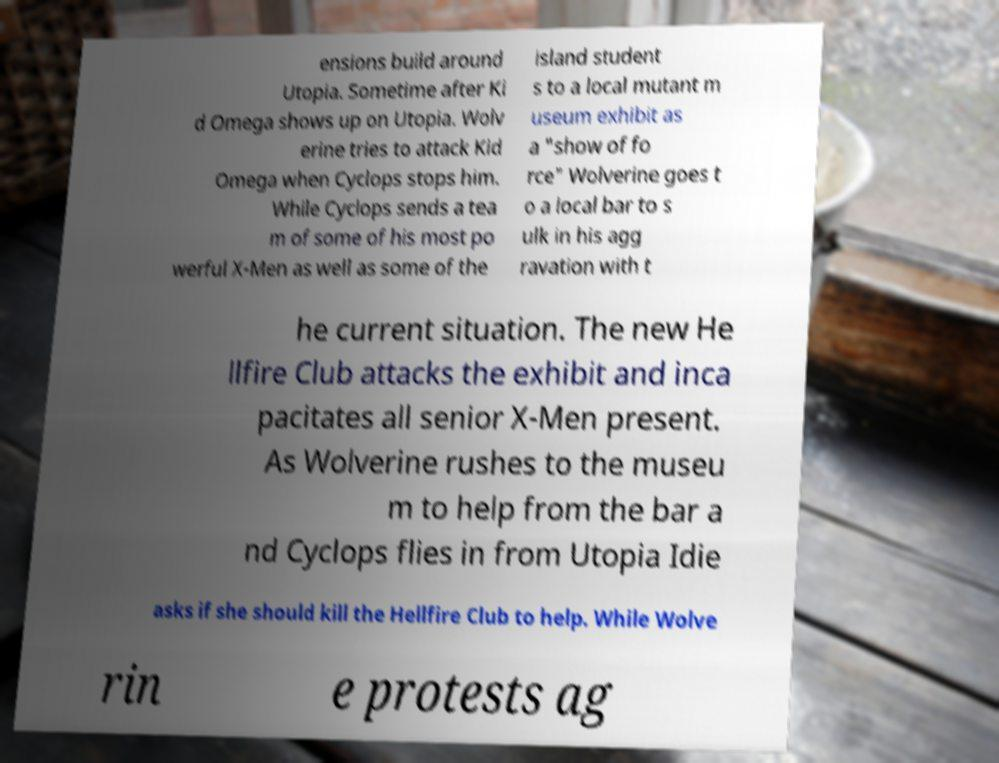Could you extract and type out the text from this image? ensions build around Utopia. Sometime after Ki d Omega shows up on Utopia. Wolv erine tries to attack Kid Omega when Cyclops stops him. While Cyclops sends a tea m of some of his most po werful X-Men as well as some of the island student s to a local mutant m useum exhibit as a "show of fo rce" Wolverine goes t o a local bar to s ulk in his agg ravation with t he current situation. The new He llfire Club attacks the exhibit and inca pacitates all senior X-Men present. As Wolverine rushes to the museu m to help from the bar a nd Cyclops flies in from Utopia Idie asks if she should kill the Hellfire Club to help. While Wolve rin e protests ag 